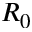<formula> <loc_0><loc_0><loc_500><loc_500>R _ { 0 }</formula> 